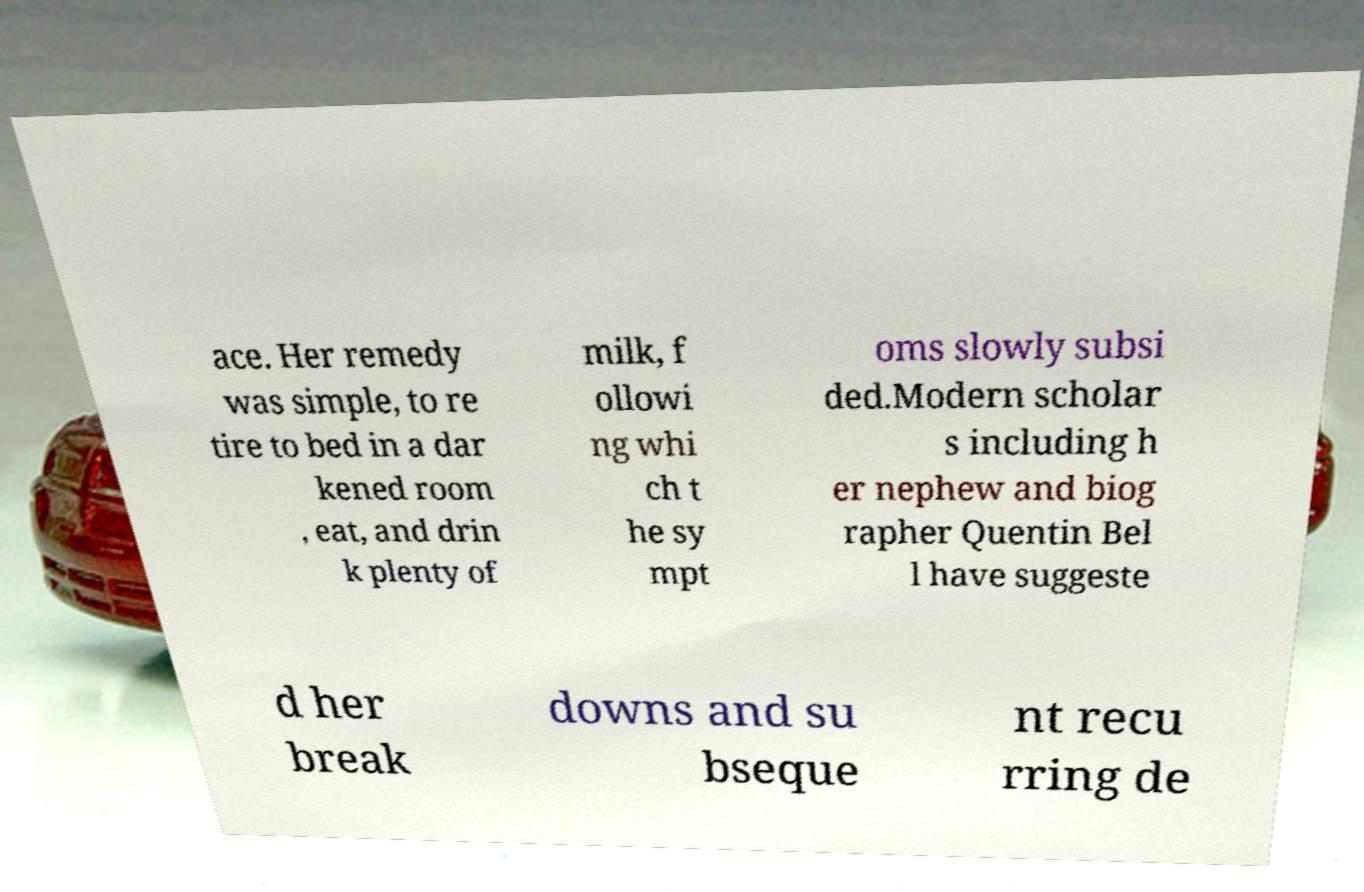Please read and relay the text visible in this image. What does it say? ace. Her remedy was simple, to re tire to bed in a dar kened room , eat, and drin k plenty of milk, f ollowi ng whi ch t he sy mpt oms slowly subsi ded.Modern scholar s including h er nephew and biog rapher Quentin Bel l have suggeste d her break downs and su bseque nt recu rring de 